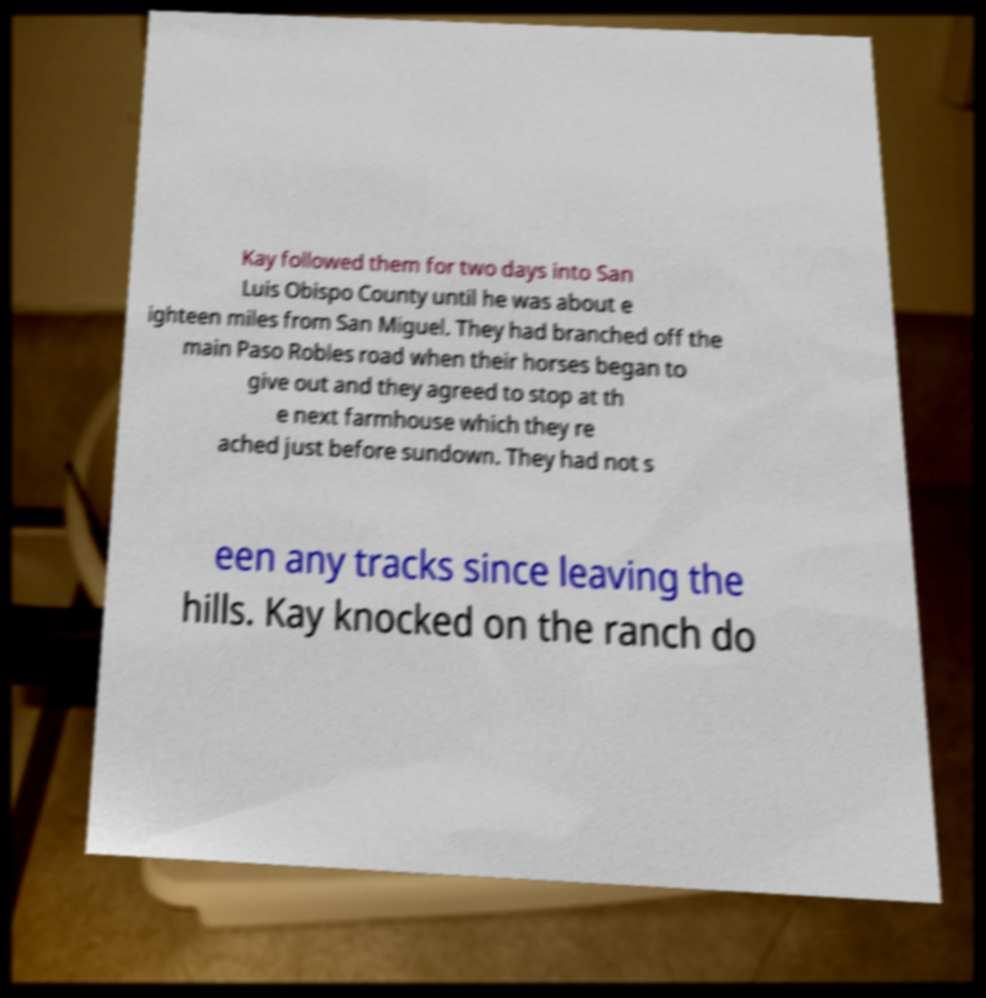For documentation purposes, I need the text within this image transcribed. Could you provide that? Kay followed them for two days into San Luis Obispo County until he was about e ighteen miles from San Miguel. They had branched off the main Paso Robles road when their horses began to give out and they agreed to stop at th e next farmhouse which they re ached just before sundown. They had not s een any tracks since leaving the hills. Kay knocked on the ranch do 